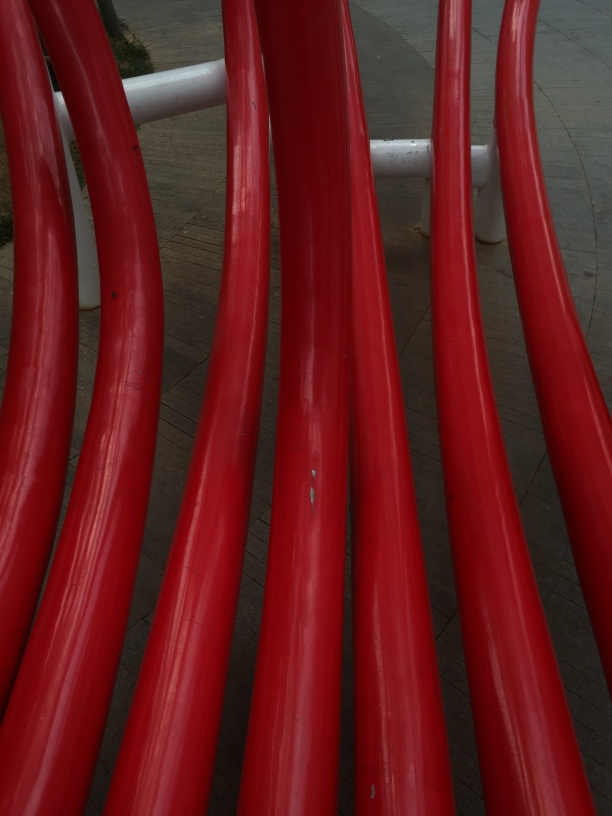Are there any quality issues with this image? Yes, the image appears to have some focus blur and poor lighting conditions, which reduce its overall sharpness and detail visibility. Additionally, there are minor marks and blemishes visible on the red curved structures, suggesting either damage to the objects or dirt on the camera lens. 